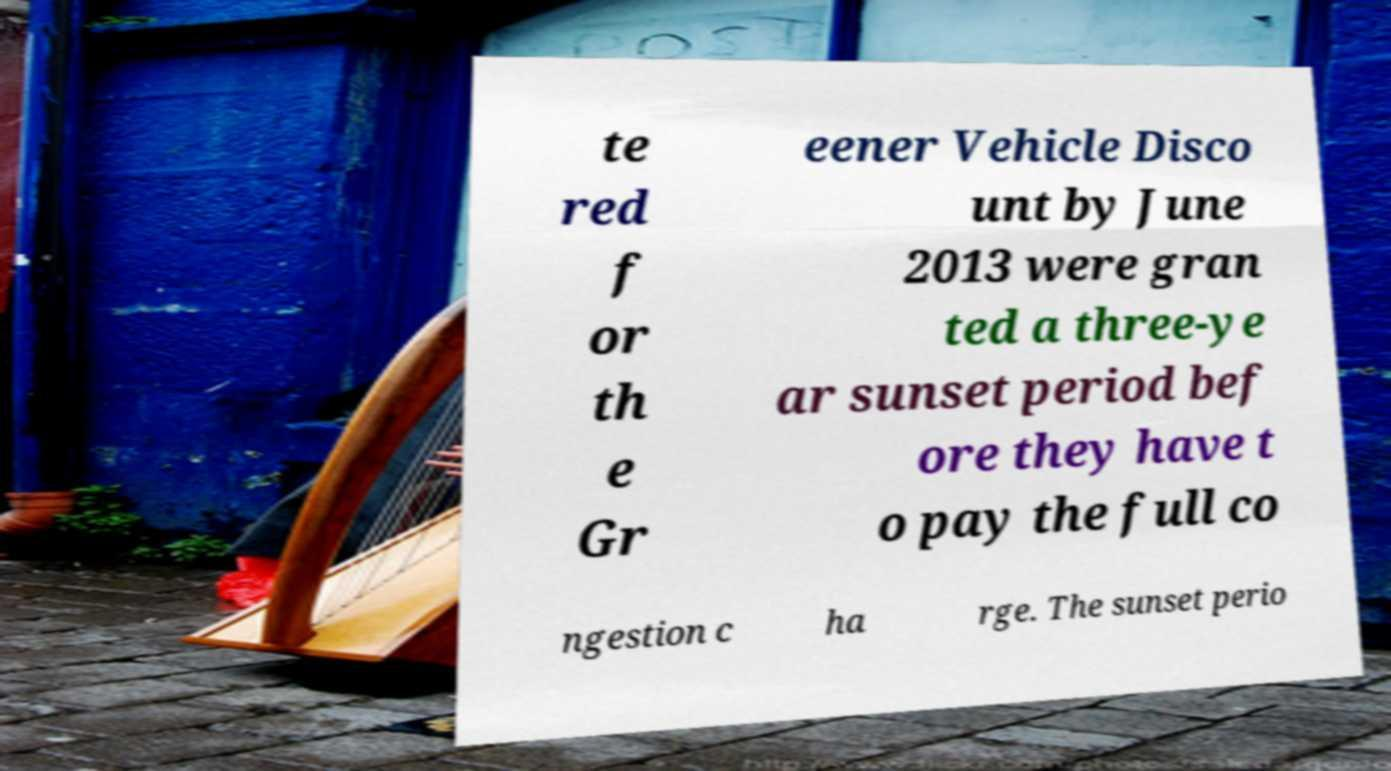For documentation purposes, I need the text within this image transcribed. Could you provide that? te red f or th e Gr eener Vehicle Disco unt by June 2013 were gran ted a three-ye ar sunset period bef ore they have t o pay the full co ngestion c ha rge. The sunset perio 